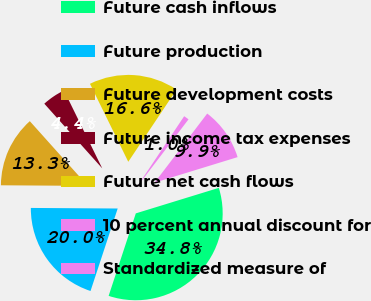<chart> <loc_0><loc_0><loc_500><loc_500><pie_chart><fcel>Future cash inflows<fcel>Future production<fcel>Future development costs<fcel>Future income tax expenses<fcel>Future net cash flows<fcel>10 percent annual discount for<fcel>Standardized measure of<nl><fcel>34.81%<fcel>20.04%<fcel>13.27%<fcel>4.36%<fcel>16.65%<fcel>0.98%<fcel>9.89%<nl></chart> 